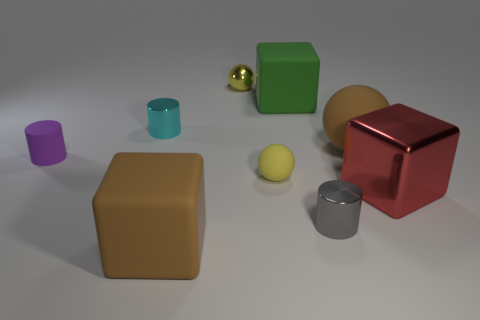Add 1 yellow balls. How many objects exist? 10 Subtract all cubes. How many objects are left? 6 Add 1 big blocks. How many big blocks exist? 4 Subtract 1 brown balls. How many objects are left? 8 Subtract all small cylinders. Subtract all big yellow cylinders. How many objects are left? 6 Add 8 small yellow spheres. How many small yellow spheres are left? 10 